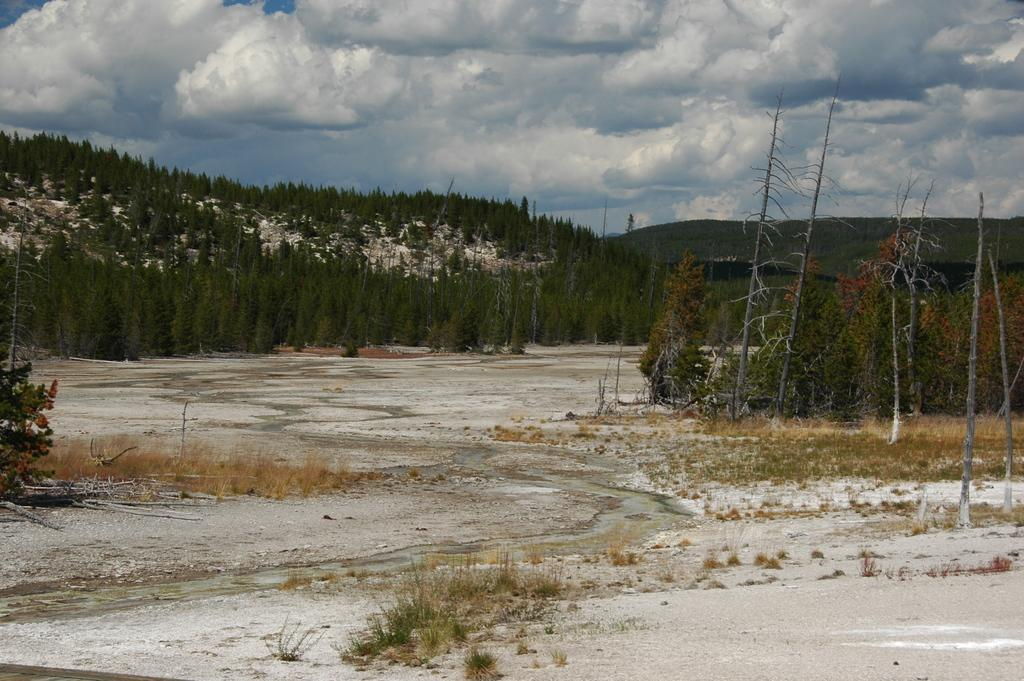What type of living organisms can be seen in the image? Plants can be seen in the image. What can be seen in the background of the image? There are trees in the background of the image. What is visible in the sky in the image? The sky is visible in the image, and clouds are present. What type of stick is being used by the plants in the image? There is no stick present in the image, and the plants do not use any tools. 